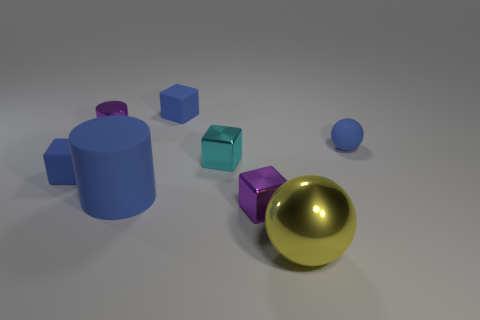Is the material of the tiny cylinder the same as the small blue cube left of the big blue object?
Your answer should be compact. No. Is there anything else that has the same material as the tiny cylinder?
Keep it short and to the point. Yes. Are there more yellow metallic things than small purple things?
Provide a succinct answer. No. There is a small blue object in front of the metal cube behind the small object that is on the left side of the small metal cylinder; what shape is it?
Give a very brief answer. Cube. Is the material of the ball that is behind the yellow object the same as the purple cylinder that is on the left side of the big yellow metal object?
Your answer should be compact. No. There is a yellow object that is made of the same material as the cyan object; what is its shape?
Your response must be concise. Sphere. Is there anything else that has the same color as the small ball?
Your response must be concise. Yes. What number of small blue blocks are there?
Your answer should be compact. 2. The blue block that is behind the small blue object that is to the right of the yellow ball is made of what material?
Offer a terse response. Rubber. What color is the shiny cube that is in front of the small blue matte thing in front of the small matte object that is to the right of the tiny cyan thing?
Keep it short and to the point. Purple. 